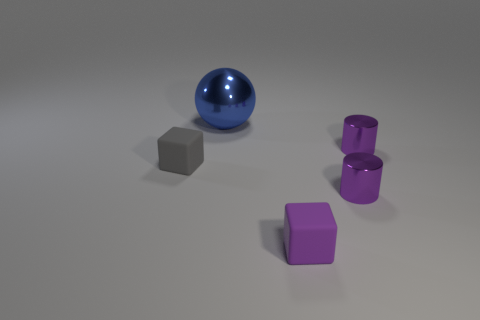If this image were part of a visual art test, what question would you predict could be asked? If this image was part of a visual art test, one might be asked to analyze the use of color and form, such as 'Discuss the interplay between geometric forms and their colors in the composition.' Another potential question could focus on lighting and shadow: 'Examine how lighting impacts the perception of three-dimensional objects in two-dimensional space.' Such questions invite critical observation and interpretation of the visual elements. 